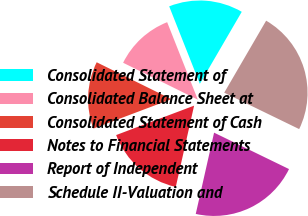Convert chart to OTSL. <chart><loc_0><loc_0><loc_500><loc_500><pie_chart><fcel>Consolidated Statement of<fcel>Consolidated Balance Sheet at<fcel>Consolidated Statement of Cash<fcel>Notes to Financial Statements<fcel>Report of Independent<fcel>Schedule II-Valuation and<nl><fcel>14.39%<fcel>11.7%<fcel>13.04%<fcel>15.73%<fcel>21.33%<fcel>23.81%<nl></chart> 